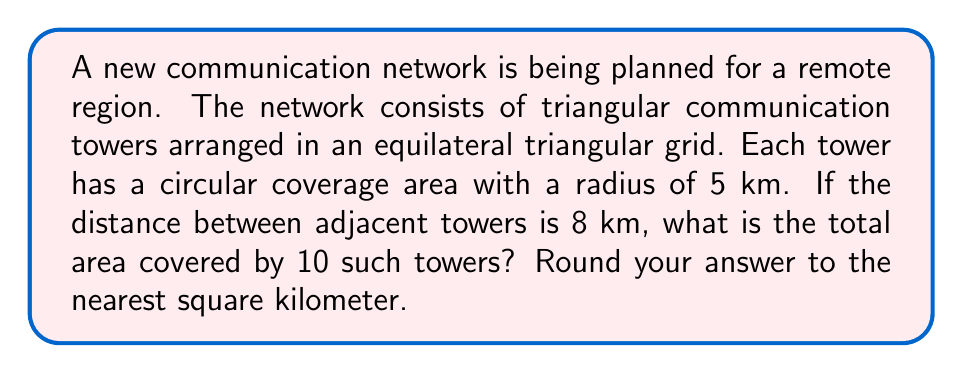Teach me how to tackle this problem. Let's approach this step-by-step:

1) First, we need to calculate the area covered by a single tower:
   Area of a circle = $\pi r^2$
   $A = \pi (5 \text{ km})^2 = 25\pi \text{ km}^2$

2) However, the circles will overlap. To account for this, we can calculate the area of the equilateral triangle formed by three adjacent towers and compare it to the area of three circles.

3) The area of an equilateral triangle with side length $a$ is:
   $A_{\triangle} = \frac{\sqrt{3}}{4}a^2$
   
   With $a = 8 \text{ km}$:
   $A_{\triangle} = \frac{\sqrt{3}}{4}(8 \text{ km})^2 = 27.71 \text{ km}^2$

4) The area of three circles is:
   $3 \times 25\pi \text{ km}^2 = 75\pi \text{ km}^2 = 235.62 \text{ km}^2$

5) The ratio of actual coverage to the sum of individual coverages is:
   $\frac{27.71}{235.62} = 0.1176$

6) Therefore, the effective coverage of each tower is:
   $25\pi \text{ km}^2 \times 0.1176 = 9.25 \text{ km}^2$

7) For 10 towers, the total coverage is:
   $10 \times 9.25 \text{ km}^2 = 92.5 \text{ km}^2$

8) Rounding to the nearest square kilometer:
   $92.5 \text{ km}^2 \approx 93 \text{ km}^2$
Answer: 93 km² 